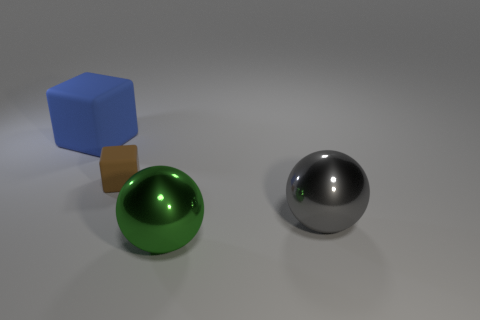What color is the thing that is behind the green ball and right of the brown block?
Give a very brief answer. Gray. Is the size of the cube that is behind the brown object the same as the gray shiny thing?
Provide a succinct answer. Yes. Is the material of the tiny thing the same as the big green sphere that is on the right side of the brown object?
Your answer should be compact. No. How many brown things are tiny rubber blocks or big shiny things?
Offer a very short reply. 1. Are any small brown blocks visible?
Keep it short and to the point. Yes. There is a metallic ball behind the sphere in front of the gray ball; is there a metal thing that is in front of it?
Keep it short and to the point. Yes. Are there any other things that have the same size as the brown thing?
Offer a terse response. No. Do the blue matte object and the thing that is in front of the gray shiny thing have the same shape?
Provide a short and direct response. No. What is the color of the large object that is behind the sphere to the right of the shiny ball on the left side of the big gray metal thing?
Ensure brevity in your answer.  Blue. How many objects are either blocks that are to the left of the brown rubber block or rubber things that are in front of the big blue cube?
Offer a very short reply. 2. 